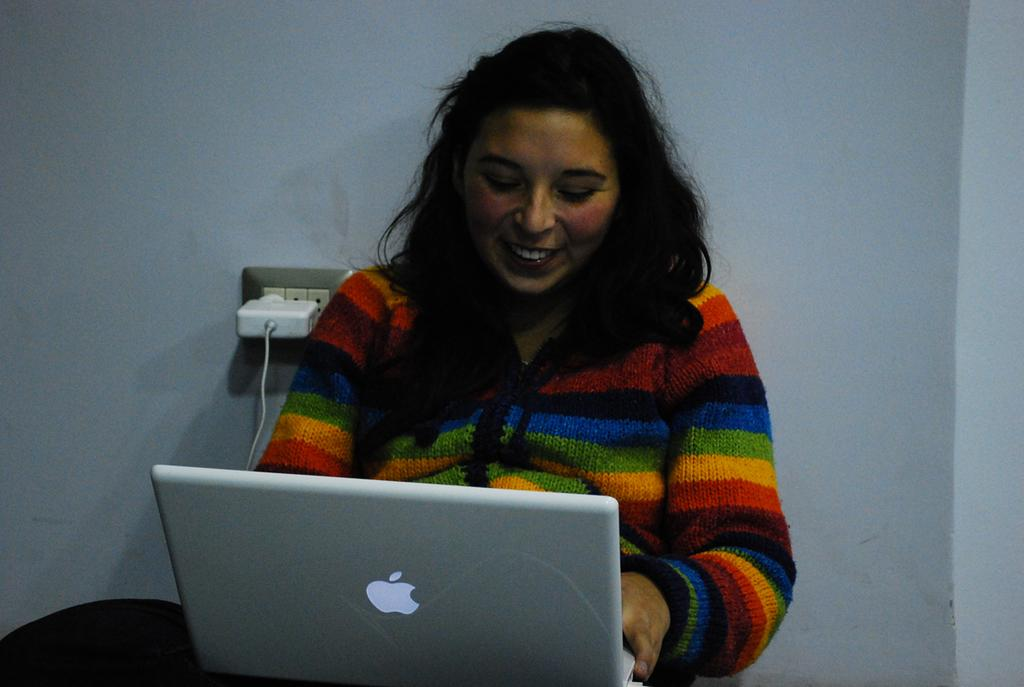Who is present in the image? There is a woman in the image. What is the woman's expression? The woman is smiling. What object is in front of the woman? There is a laptop in front of the woman. What can be seen in the background of the image? There is a cable, a device, a switch board, and a wall in the background of the image. What type of plants can be seen growing near the sink in the image? There is no sink or plants present in the image. What flavor of soda is the woman drinking in the image? There is no soda visible in the image. 